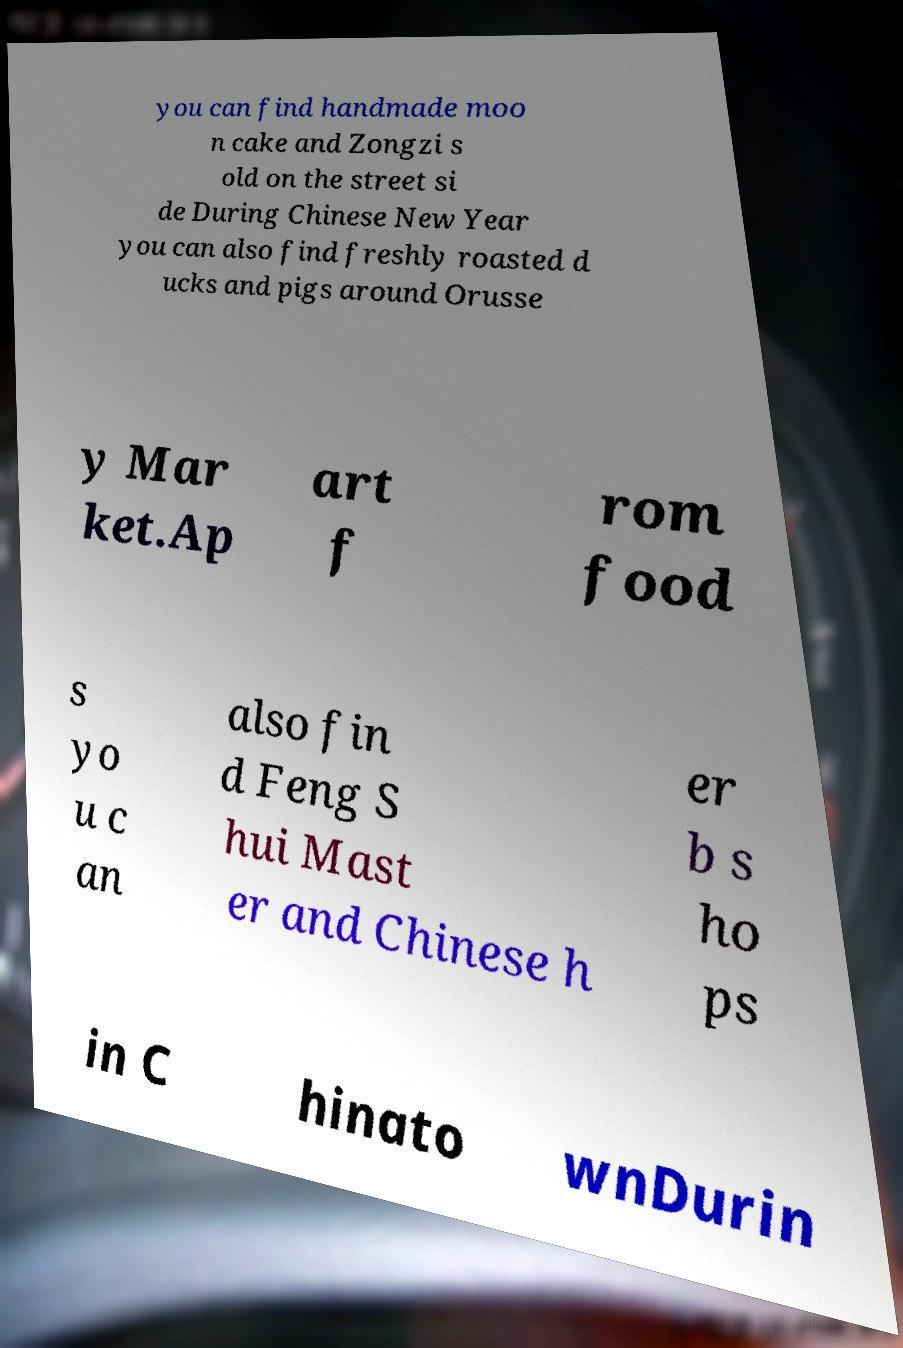Could you assist in decoding the text presented in this image and type it out clearly? you can find handmade moo n cake and Zongzi s old on the street si de During Chinese New Year you can also find freshly roasted d ucks and pigs around Orusse y Mar ket.Ap art f rom food s yo u c an also fin d Feng S hui Mast er and Chinese h er b s ho ps in C hinato wnDurin 